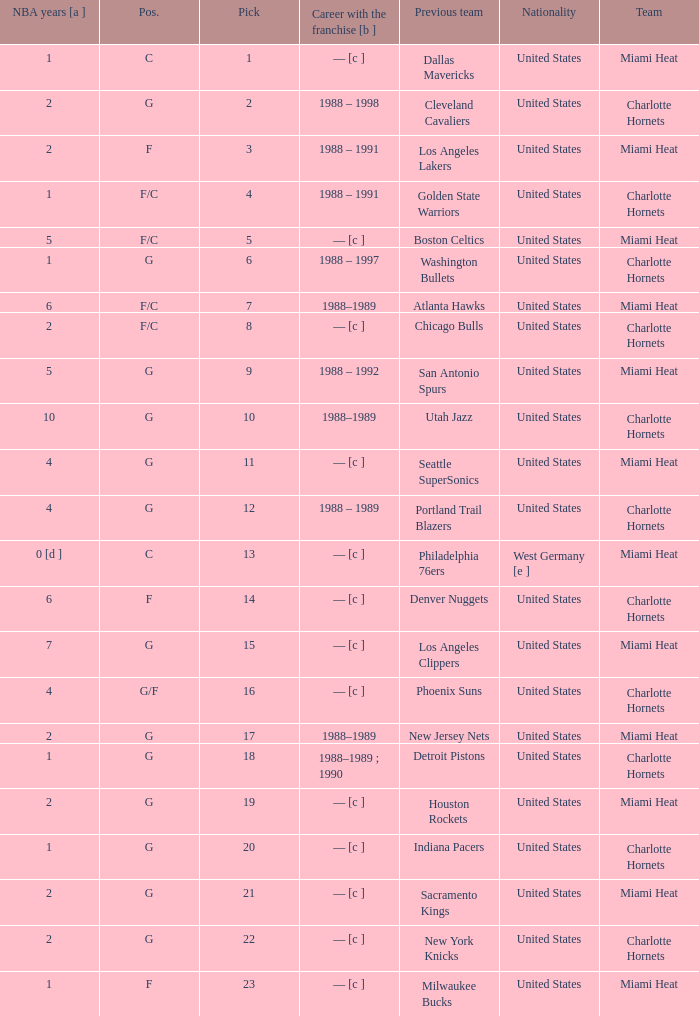What is the previous team of the player with 4 NBA years and a pick less than 16? Seattle SuperSonics, Portland Trail Blazers. 